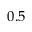Convert formula to latex. <formula><loc_0><loc_0><loc_500><loc_500>0 . 5</formula> 